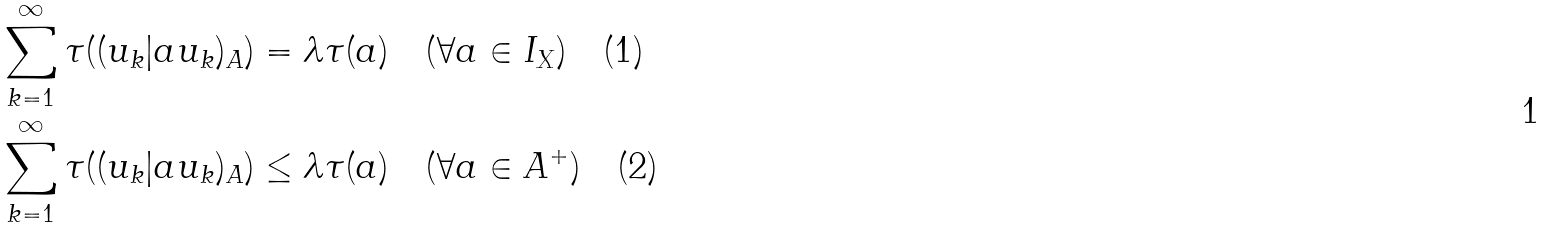Convert formula to latex. <formula><loc_0><loc_0><loc_500><loc_500>\sum _ { k = 1 } ^ { \infty } \tau ( ( u _ { k } | a u _ { k } ) _ { A } ) & = \lambda \tau ( a ) \quad ( \forall a \in I _ { X } ) \quad ( 1 ) \\ \sum _ { k = 1 } ^ { \infty } \tau ( ( u _ { k } | a u _ { k } ) _ { A } ) & \leq \lambda \tau ( a ) \quad ( \forall a \in A ^ { + } ) \quad ( 2 )</formula> 